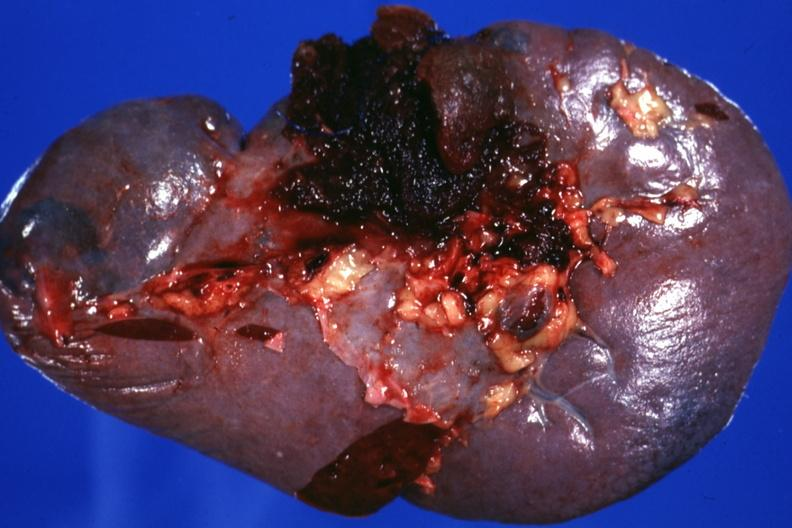s retroperitoneal liposarcoma present?
Answer the question using a single word or phrase. No 